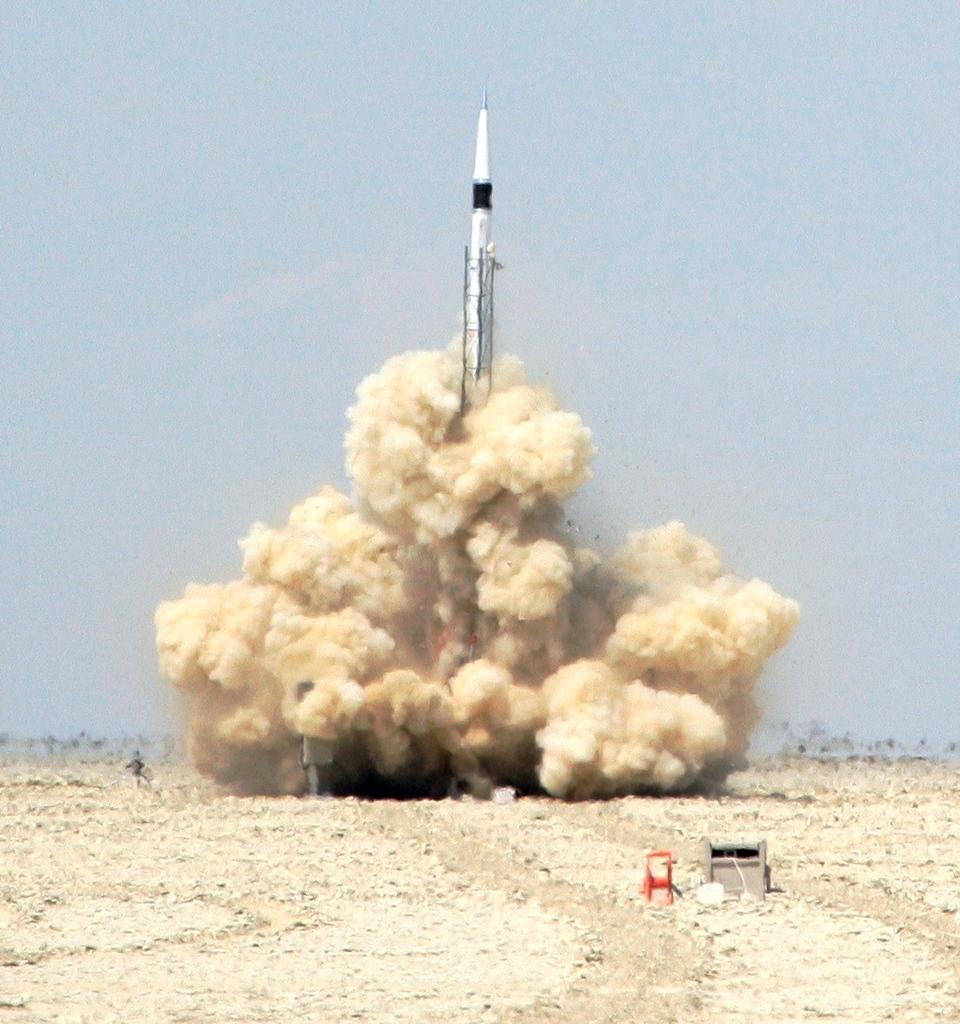Can you describe this image briefly? In this image there is a rocket in the middle which is ready to leave. At the bottom there is sand. In the background there are trees at some distance. There is full of dust around the rocket. At the top there is the sky. On the right side bottom there is a box. 